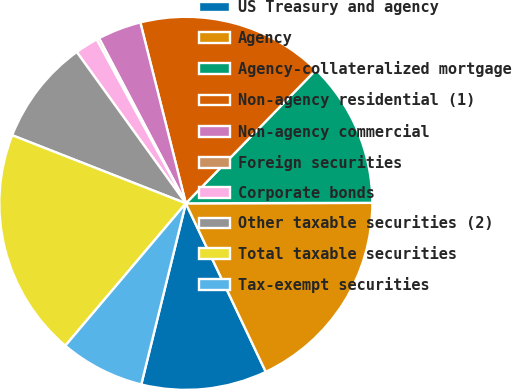<chart> <loc_0><loc_0><loc_500><loc_500><pie_chart><fcel>US Treasury and agency<fcel>Agency<fcel>Agency-collateralized mortgage<fcel>Non-agency residential (1)<fcel>Non-agency commercial<fcel>Foreign securities<fcel>Corporate bonds<fcel>Other taxable securities (2)<fcel>Total taxable securities<fcel>Tax-exempt securities<nl><fcel>10.89%<fcel>17.99%<fcel>12.66%<fcel>16.22%<fcel>3.78%<fcel>0.23%<fcel>2.01%<fcel>9.11%<fcel>19.77%<fcel>7.34%<nl></chart> 